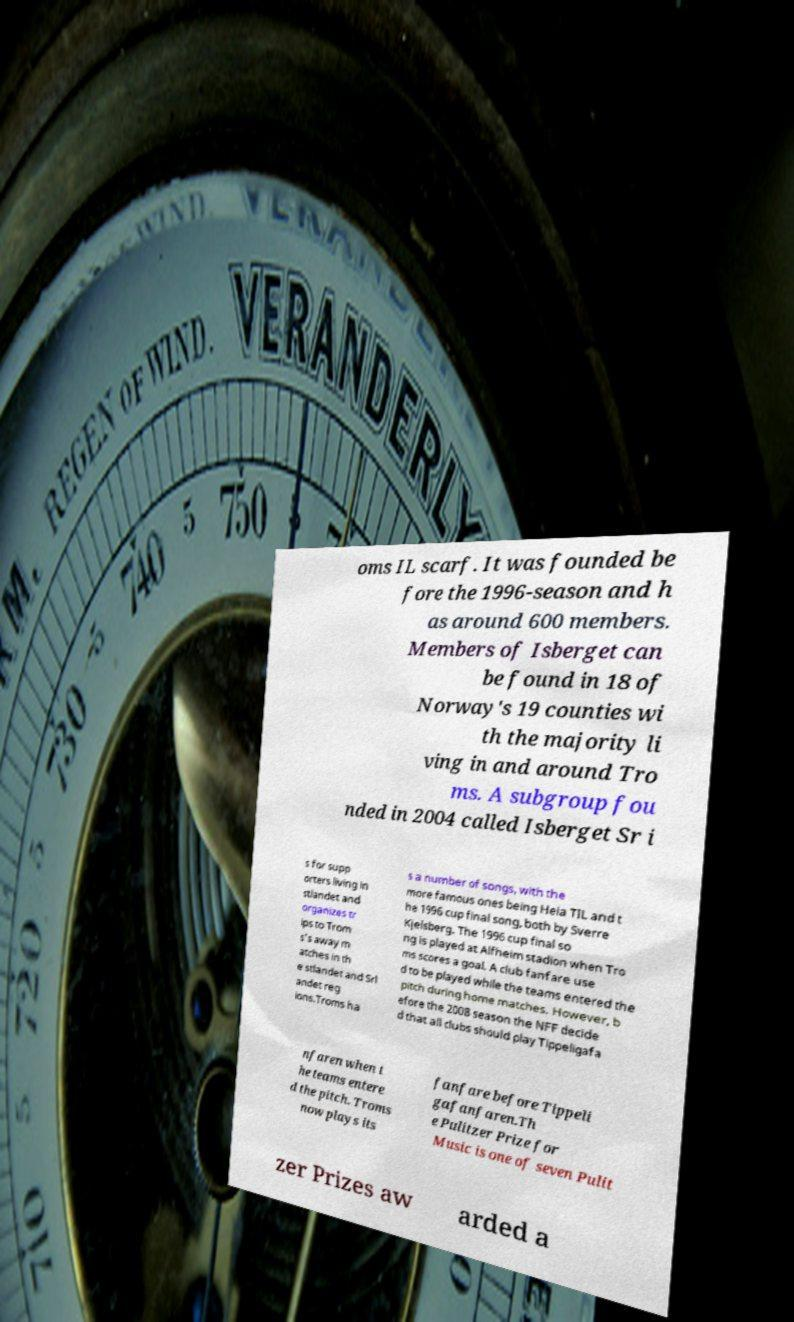Please read and relay the text visible in this image. What does it say? oms IL scarf. It was founded be fore the 1996-season and h as around 600 members. Members of Isberget can be found in 18 of Norway's 19 counties wi th the majority li ving in and around Tro ms. A subgroup fou nded in 2004 called Isberget Sr i s for supp orters living in stlandet and organizes tr ips to Trom s's away m atches in th e stlandet and Srl andet reg ions.Troms ha s a number of songs, with the more famous ones being Heia TIL and t he 1996 cup final song, both by Sverre Kjelsberg. The 1996 cup final so ng is played at Alfheim stadion when Tro ms scores a goal. A club fanfare use d to be played while the teams entered the pitch during home matches. However, b efore the 2008 season the NFF decide d that all clubs should play Tippeligafa nfaren when t he teams entere d the pitch. Troms now plays its fanfare before Tippeli gafanfaren.Th e Pulitzer Prize for Music is one of seven Pulit zer Prizes aw arded a 